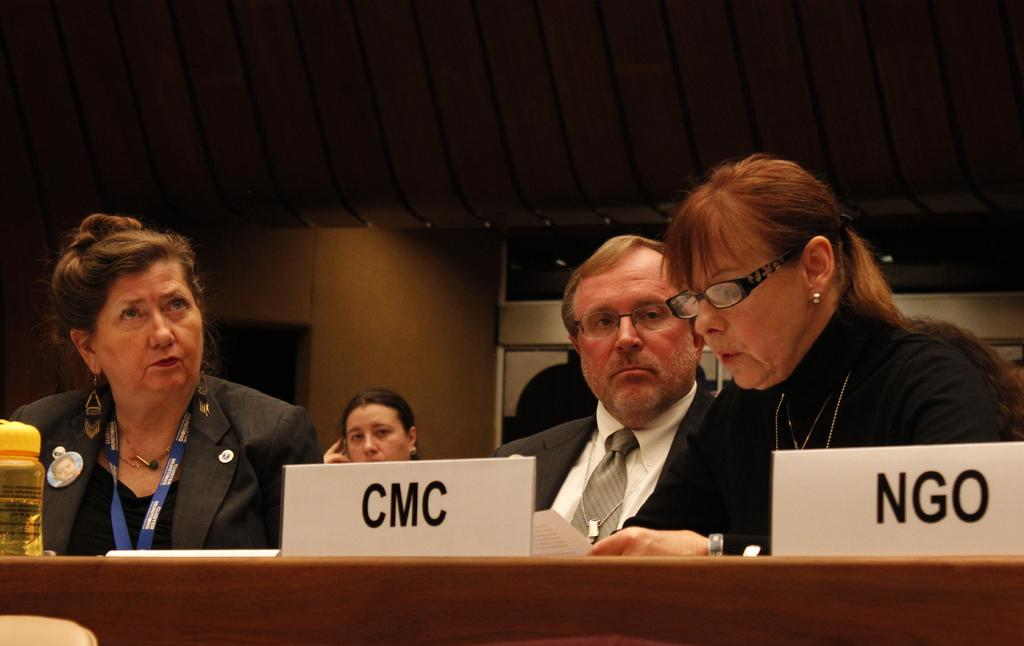How many people are present in the room? There are four people sitting in the room. What is the woman holding in the room? The woman is holding a paper. What piece of furniture is present in the room? There is a table in the room. What type of items can be seen on the walls in the room? There are two boards with text in the room. What is placed on the table in the room? There is a bottle on the table. How many dogs are visible in the room? There are no dogs visible in the room. What type of current is flowing through the bottle in the room? There is no indication of any current flowing through the bottle in the room. 